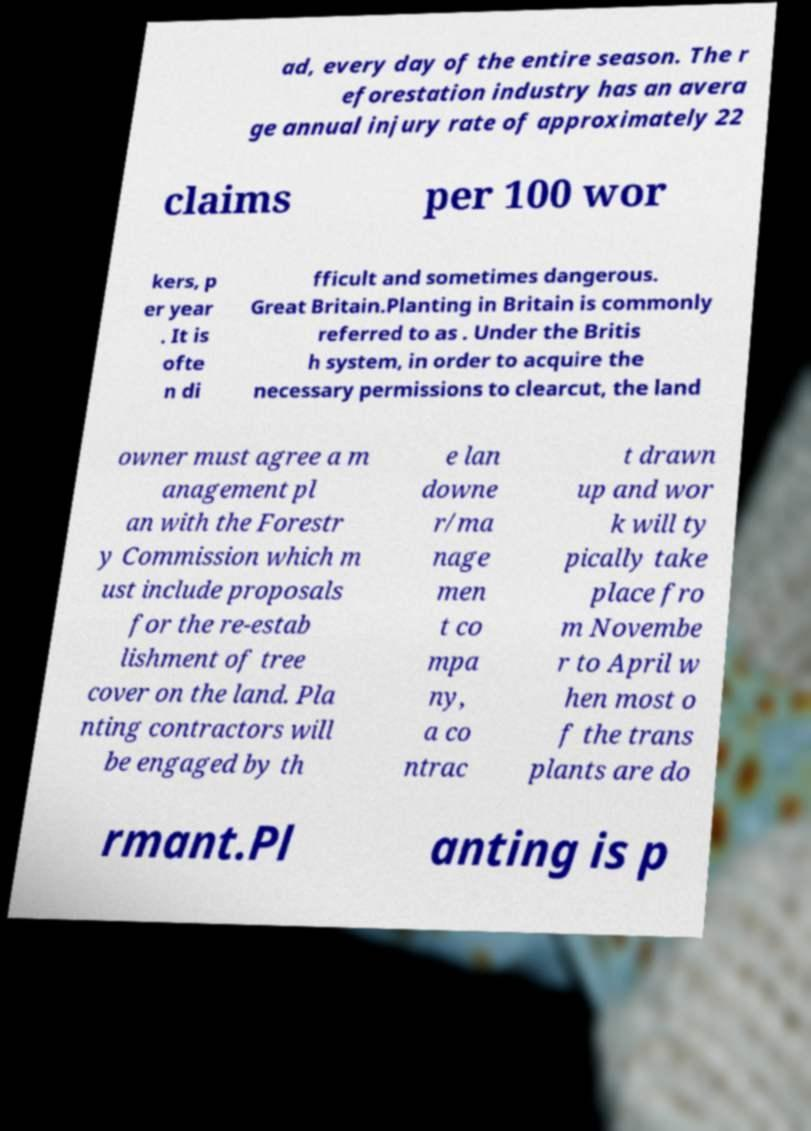For documentation purposes, I need the text within this image transcribed. Could you provide that? ad, every day of the entire season. The r eforestation industry has an avera ge annual injury rate of approximately 22 claims per 100 wor kers, p er year . It is ofte n di fficult and sometimes dangerous. Great Britain.Planting in Britain is commonly referred to as . Under the Britis h system, in order to acquire the necessary permissions to clearcut, the land owner must agree a m anagement pl an with the Forestr y Commission which m ust include proposals for the re-estab lishment of tree cover on the land. Pla nting contractors will be engaged by th e lan downe r/ma nage men t co mpa ny, a co ntrac t drawn up and wor k will ty pically take place fro m Novembe r to April w hen most o f the trans plants are do rmant.Pl anting is p 